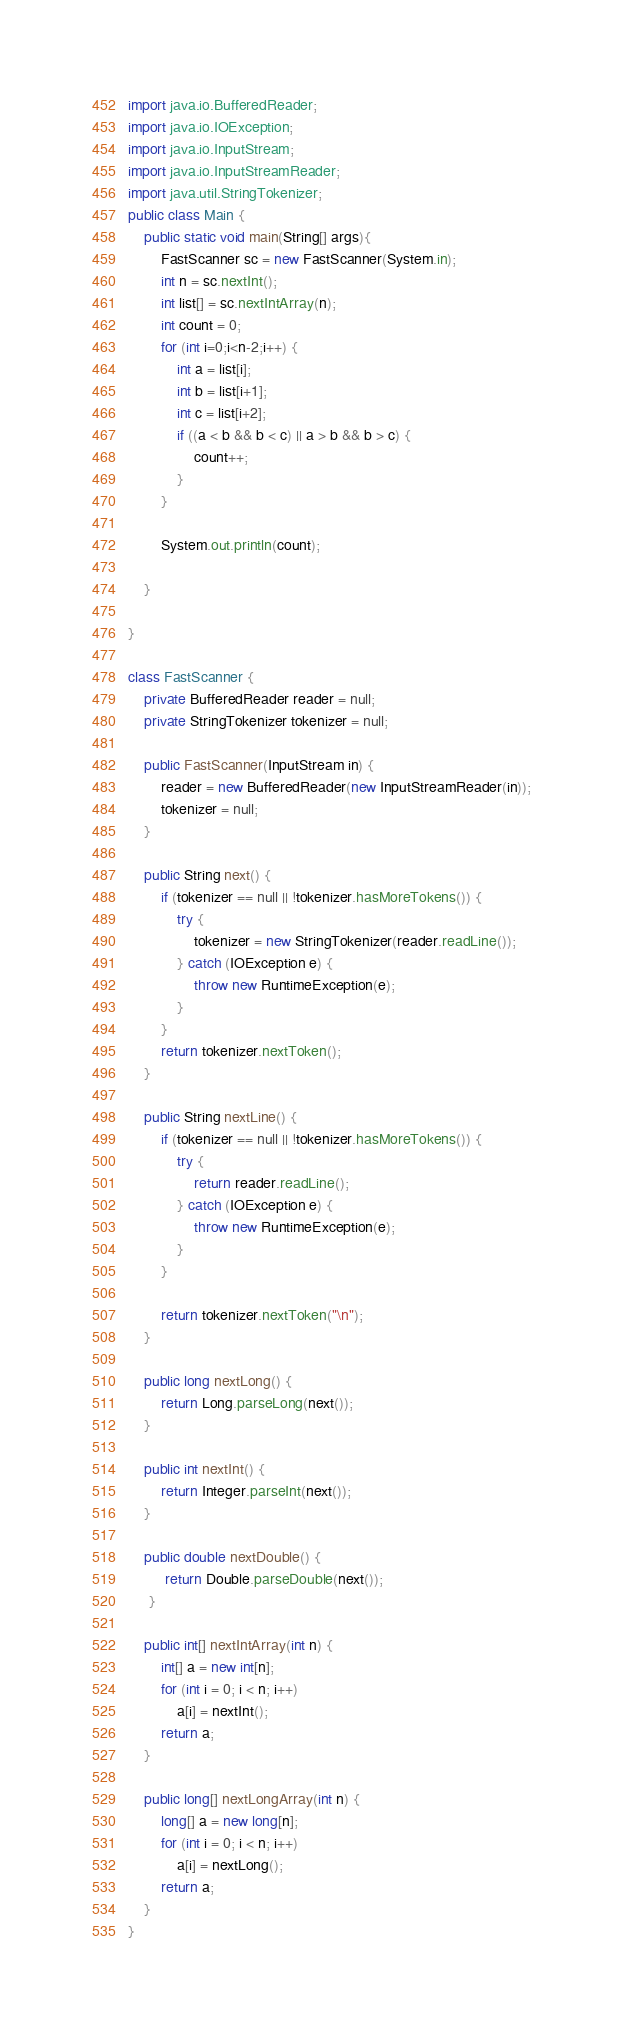<code> <loc_0><loc_0><loc_500><loc_500><_Java_>import java.io.BufferedReader;
import java.io.IOException;
import java.io.InputStream;
import java.io.InputStreamReader;
import java.util.StringTokenizer;
public class Main {
	public static void main(String[] args){
		FastScanner sc = new FastScanner(System.in);
		int n = sc.nextInt();
		int list[] = sc.nextIntArray(n);
		int count = 0;
		for (int i=0;i<n-2;i++) {
			int a = list[i];
			int b = list[i+1];
			int c = list[i+2];
			if ((a < b && b < c) || a > b && b > c) {
				count++;
			}
		}

		System.out.println(count);

	}

}

class FastScanner {
    private BufferedReader reader = null;
    private StringTokenizer tokenizer = null;

    public FastScanner(InputStream in) {
        reader = new BufferedReader(new InputStreamReader(in));
        tokenizer = null;
    }

    public String next() {
        if (tokenizer == null || !tokenizer.hasMoreTokens()) {
            try {
                tokenizer = new StringTokenizer(reader.readLine());
            } catch (IOException e) {
                throw new RuntimeException(e);
            }
        }
        return tokenizer.nextToken();
    }

    public String nextLine() {
        if (tokenizer == null || !tokenizer.hasMoreTokens()) {
            try {
                return reader.readLine();
            } catch (IOException e) {
                throw new RuntimeException(e);
            }
        }

        return tokenizer.nextToken("\n");
    }

    public long nextLong() {
        return Long.parseLong(next());
    }

    public int nextInt() {
        return Integer.parseInt(next());
    }

    public double nextDouble() {
         return Double.parseDouble(next());
     }

    public int[] nextIntArray(int n) {
        int[] a = new int[n];
        for (int i = 0; i < n; i++)
            a[i] = nextInt();
        return a;
    }

    public long[] nextLongArray(int n) {
        long[] a = new long[n];
        for (int i = 0; i < n; i++)
            a[i] = nextLong();
        return a;
    }
}</code> 